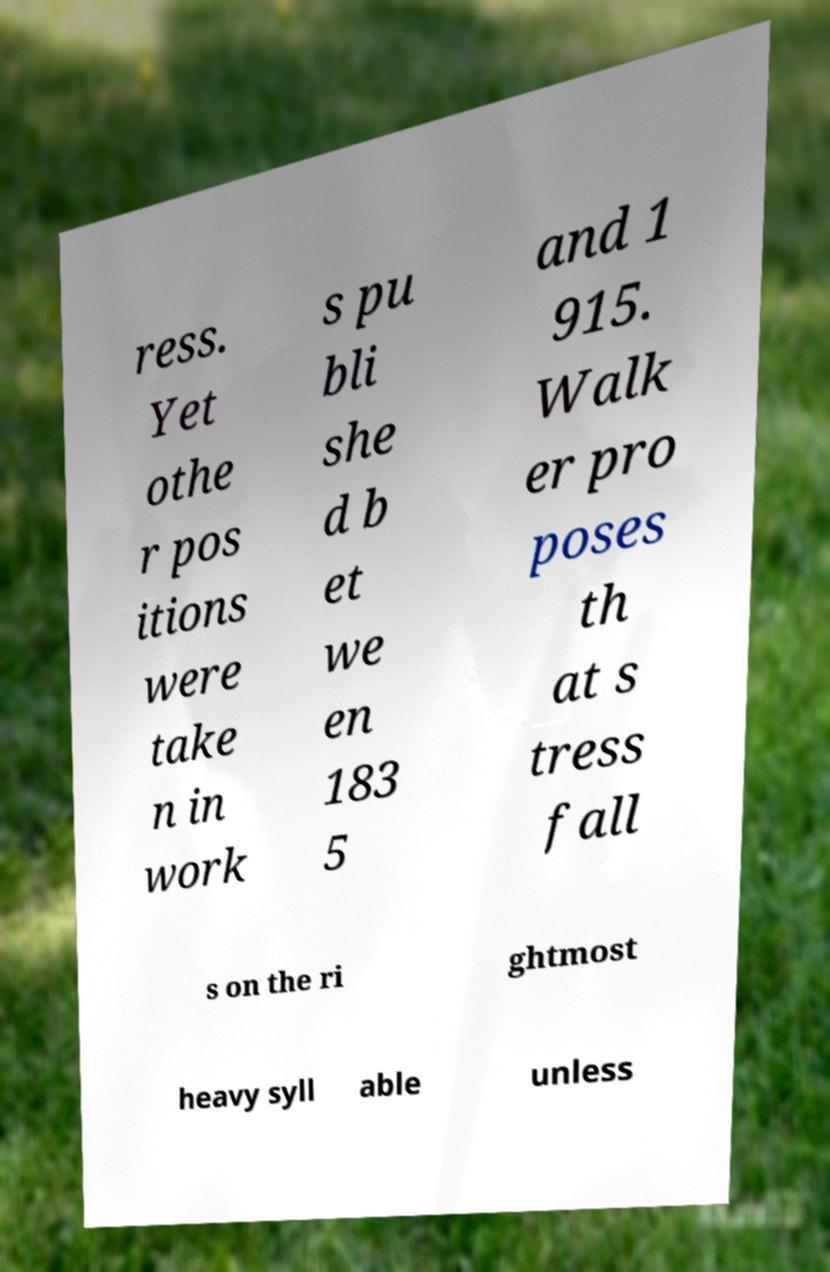Please read and relay the text visible in this image. What does it say? ress. Yet othe r pos itions were take n in work s pu bli she d b et we en 183 5 and 1 915. Walk er pro poses th at s tress fall s on the ri ghtmost heavy syll able unless 